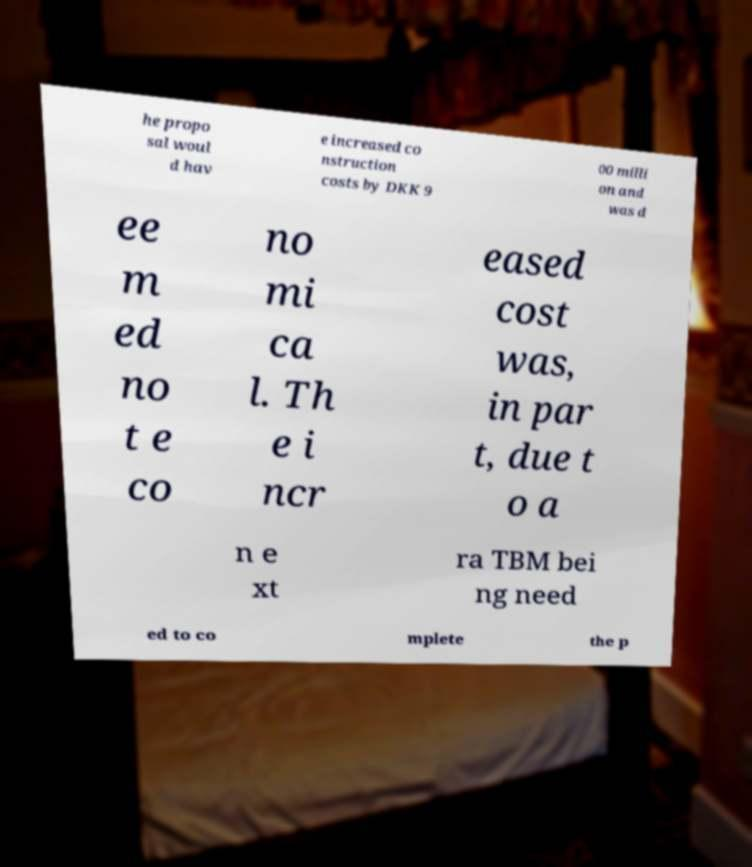I need the written content from this picture converted into text. Can you do that? he propo sal woul d hav e increased co nstruction costs by DKK 9 00 milli on and was d ee m ed no t e co no mi ca l. Th e i ncr eased cost was, in par t, due t o a n e xt ra TBM bei ng need ed to co mplete the p 